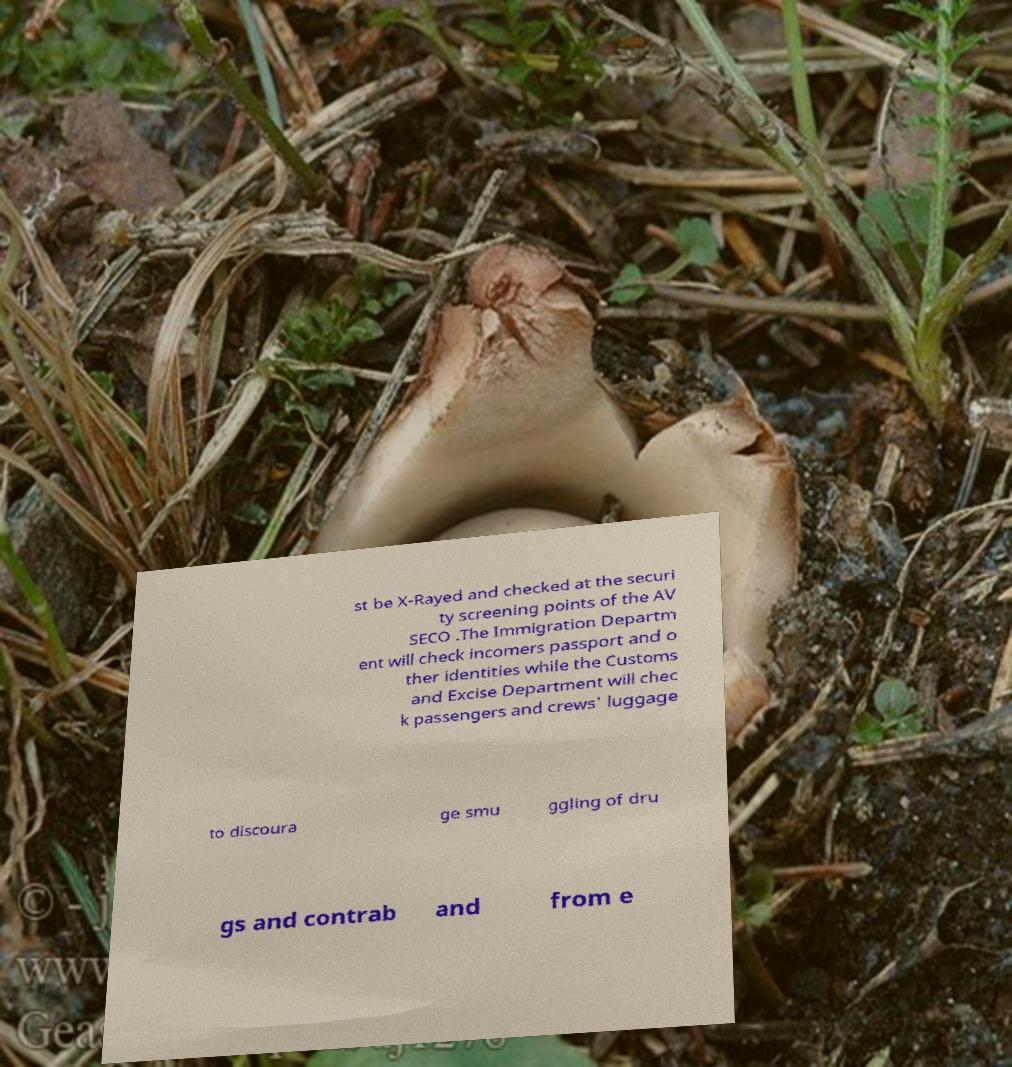Can you accurately transcribe the text from the provided image for me? st be X-Rayed and checked at the securi ty screening points of the AV SECO .The Immigration Departm ent will check incomers passport and o ther identities while the Customs and Excise Department will chec k passengers and crews' luggage to discoura ge smu ggling of dru gs and contrab and from e 